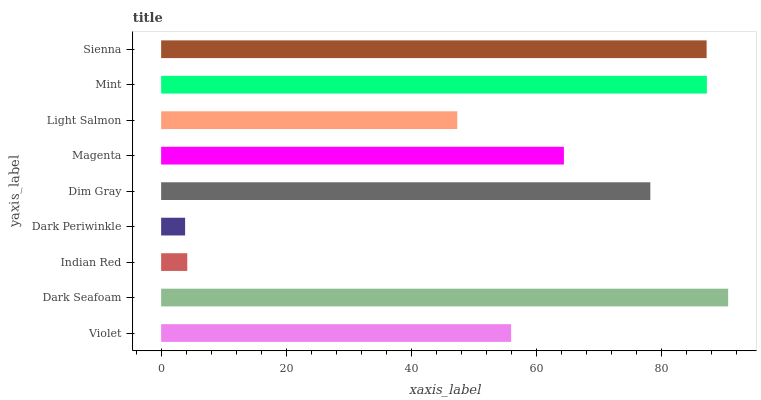Is Dark Periwinkle the minimum?
Answer yes or no. Yes. Is Dark Seafoam the maximum?
Answer yes or no. Yes. Is Indian Red the minimum?
Answer yes or no. No. Is Indian Red the maximum?
Answer yes or no. No. Is Dark Seafoam greater than Indian Red?
Answer yes or no. Yes. Is Indian Red less than Dark Seafoam?
Answer yes or no. Yes. Is Indian Red greater than Dark Seafoam?
Answer yes or no. No. Is Dark Seafoam less than Indian Red?
Answer yes or no. No. Is Magenta the high median?
Answer yes or no. Yes. Is Magenta the low median?
Answer yes or no. Yes. Is Light Salmon the high median?
Answer yes or no. No. Is Light Salmon the low median?
Answer yes or no. No. 